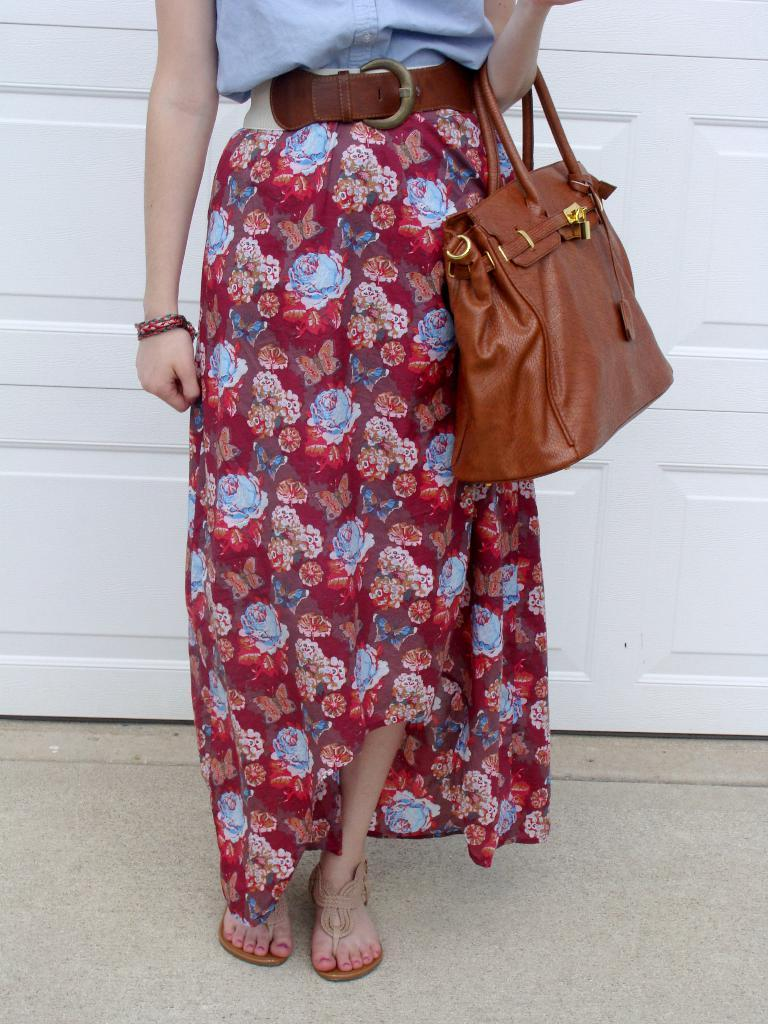Who or what is present in the image? There is a person in the image. What is the person holding or carrying? The person is carrying a bag. What can be seen in the background of the image? There is a wooden object in the background of the image. What type of memory does the ant have in the image? There is no ant present in the image, so it is not possible to determine the type of memory it might have. 